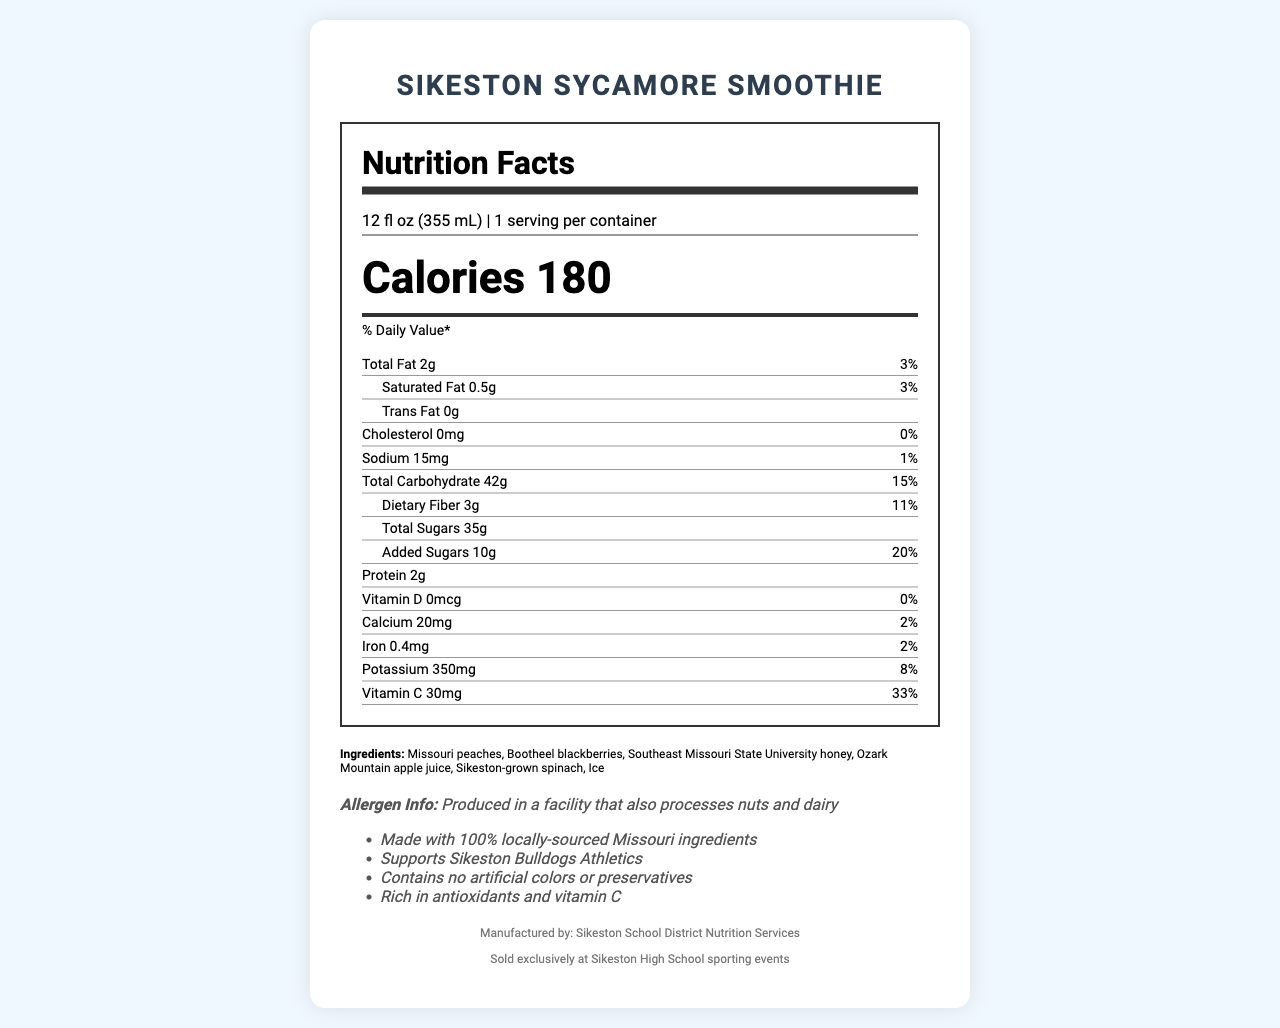what is the serving size of the Sikeston Sycamore Smoothie? The serving size is listed as "12 fl oz (355 mL)" in the document.
Answer: 12 fl oz (355 mL) how many calories are in one serving of the Sikeston Sycamore Smoothie? The calorie count is clearly marked as 180 on the label.
Answer: 180 how many grams of total fat does the Sikeston Sycamore Smoothie contain per serving? The document specifies that the total fat content per serving is 2 grams.
Answer: 2g what percentage of the daily value of dietary fiber does one serving of the Sikeston Sycamore Smoothie provide? The label indicates that the smoothie provides 11% of the daily value of dietary fiber.
Answer: 11% how much calcium is in one serving of the Sikeston Sycamore Smoothie? The amount of calcium in one serving is 20mg, as shown on the nutrition label.
Answer: 20mg what ingredient is NOT found in the Sikeston Sycamore Smoothie? A. Missouri peaches B. Bootheel blackberries C. High fructose corn syrup D. Sikeston-grown spinach The listed ingredients do not include high fructose corn syrup; they include Missouri peaches, Bootheel blackberries, and Sikeston-grown spinach.
Answer: C. High fructose corn syrup what is the total carbohydrate content in the Sikeston Sycamore Smoothie? A. 30g B. 42g C. 20g D. 50g The document states that the total carbohydrate content is 42 grams.
Answer: B. 42g is the Sikeston Sycamore Smoothie produced in a facility that processes nuts and dairy? The allergen information states that the smoothie is produced in a facility that processes nuts and dairy.
Answer: Yes describe the main purpose and key points of the document The document's main purpose is to inform consumers about the nutritional details and health benefits of the Sikeston Sycamore Smoothie while emphasizing its local sourcing and exclusive availability.
Answer: The document provides detailed nutritional information about the Sikeston Sycamore Smoothie, including calorie counts, macronutrient breakdowns, and vitamin content. It highlights the use of locally-sourced Missouri ingredients and its availability exclusively at Sikeston High School sporting events. It also notes that the smoothie contains no artificial colors or preservatives, is rich in antioxidants and vitamin C, and supports Sikeston Bulldogs Athletics. what is the annual revenue from the Sikeston Sycamore Smoothie sales? The document does not provide any information regarding the revenue from the sales of the smoothie.
Answer: Cannot be determined 